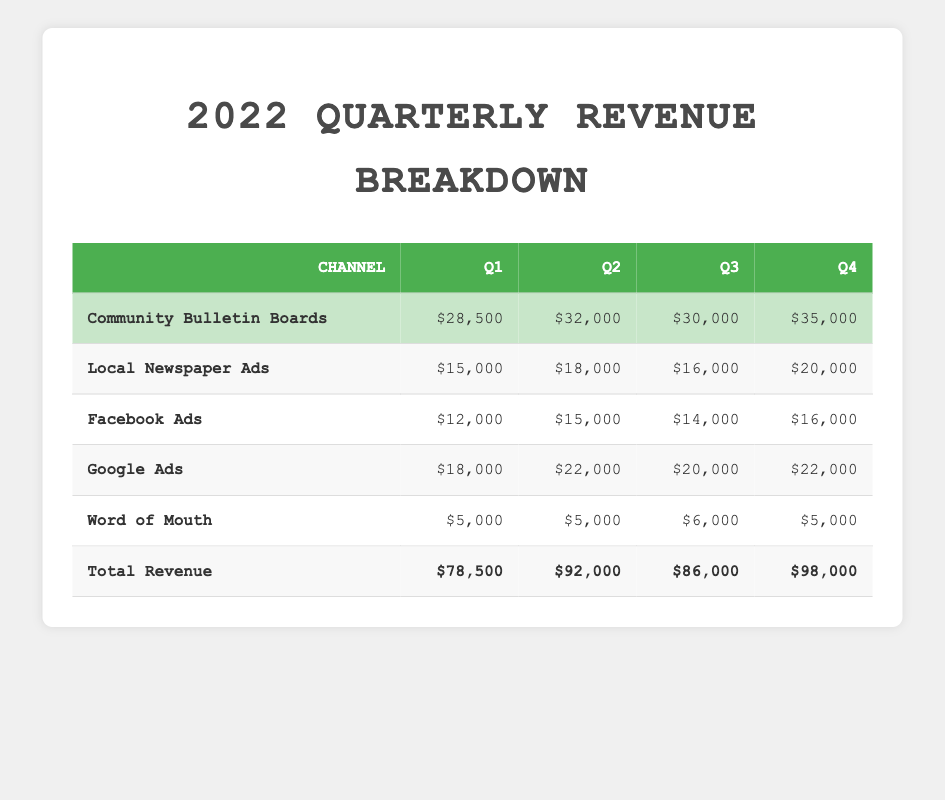What was the total revenue in Q2? The total revenue in Q2 can be found in the row labeled "Total Revenue" under the Q2 column. The value listed there is 92,000.
Answer: 92,000 Which channel generated the highest revenue in Q3? To find the channel with the highest revenue in Q3, we compare the revenue numbers in the Q3 column for each channel. The maximum value is found in the "Community Bulletin Boards" row, which is 30,000.
Answer: Community Bulletin Boards What is the average revenue from Facebook Ads over the four quarters? The Facebook Ads revenue for the four quarters is 12,000 in Q1, 15,000 in Q2, 14,000 in Q3, and 16,000 in Q4. The sum of these values is (12,000 + 15,000 + 14,000 + 16,000) = 57,000. To find the average, we divide 57,000 by 4, resulting in a value of 14,250.
Answer: 14,250 Did Community Bulletin Boards revenue increase every quarter? To check if the revenue from Community Bulletin Boards increased every quarter, we will compare Q1 to Q2, Q2 to Q3, and Q3 to Q4. The revenues are 28,500, 32,000, 30,000, and 35,000 respectively. The revenue increased from Q1 to Q2 (28,500 to 32,000), decreased from Q2 to Q3 (32,000 to 30,000), and increased again from Q3 to Q4 (30,000 to 35,000). Thus, it did not increase every quarter.
Answer: No What was the total revenue from Local Newspaper Ads in 2022? To find the total revenue from Local Newspaper Ads for the entire year, we sum the quarterly revenues: 15,000 (Q1) + 18,000 (Q2) + 16,000 (Q3) + 20,000 (Q4), which totals 69,000.
Answer: 69,000 